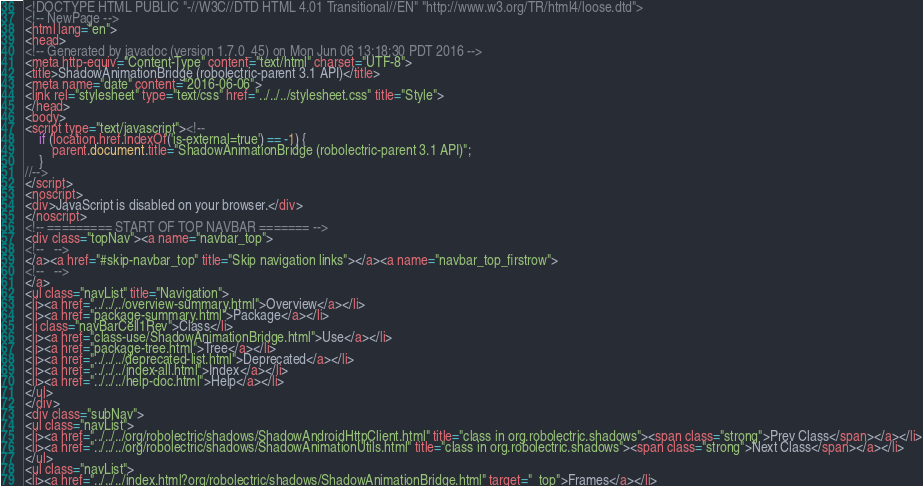Convert code to text. <code><loc_0><loc_0><loc_500><loc_500><_HTML_><!DOCTYPE HTML PUBLIC "-//W3C//DTD HTML 4.01 Transitional//EN" "http://www.w3.org/TR/html4/loose.dtd">
<!-- NewPage -->
<html lang="en">
<head>
<!-- Generated by javadoc (version 1.7.0_45) on Mon Jun 06 13:18:30 PDT 2016 -->
<meta http-equiv="Content-Type" content="text/html" charset="UTF-8">
<title>ShadowAnimationBridge (robolectric-parent 3.1 API)</title>
<meta name="date" content="2016-06-06">
<link rel="stylesheet" type="text/css" href="../../../stylesheet.css" title="Style">
</head>
<body>
<script type="text/javascript"><!--
    if (location.href.indexOf('is-external=true') == -1) {
        parent.document.title="ShadowAnimationBridge (robolectric-parent 3.1 API)";
    }
//-->
</script>
<noscript>
<div>JavaScript is disabled on your browser.</div>
</noscript>
<!-- ========= START OF TOP NAVBAR ======= -->
<div class="topNav"><a name="navbar_top">
<!--   -->
</a><a href="#skip-navbar_top" title="Skip navigation links"></a><a name="navbar_top_firstrow">
<!--   -->
</a>
<ul class="navList" title="Navigation">
<li><a href="../../../overview-summary.html">Overview</a></li>
<li><a href="package-summary.html">Package</a></li>
<li class="navBarCell1Rev">Class</li>
<li><a href="class-use/ShadowAnimationBridge.html">Use</a></li>
<li><a href="package-tree.html">Tree</a></li>
<li><a href="../../../deprecated-list.html">Deprecated</a></li>
<li><a href="../../../index-all.html">Index</a></li>
<li><a href="../../../help-doc.html">Help</a></li>
</ul>
</div>
<div class="subNav">
<ul class="navList">
<li><a href="../../../org/robolectric/shadows/ShadowAndroidHttpClient.html" title="class in org.robolectric.shadows"><span class="strong">Prev Class</span></a></li>
<li><a href="../../../org/robolectric/shadows/ShadowAnimationUtils.html" title="class in org.robolectric.shadows"><span class="strong">Next Class</span></a></li>
</ul>
<ul class="navList">
<li><a href="../../../index.html?org/robolectric/shadows/ShadowAnimationBridge.html" target="_top">Frames</a></li></code> 